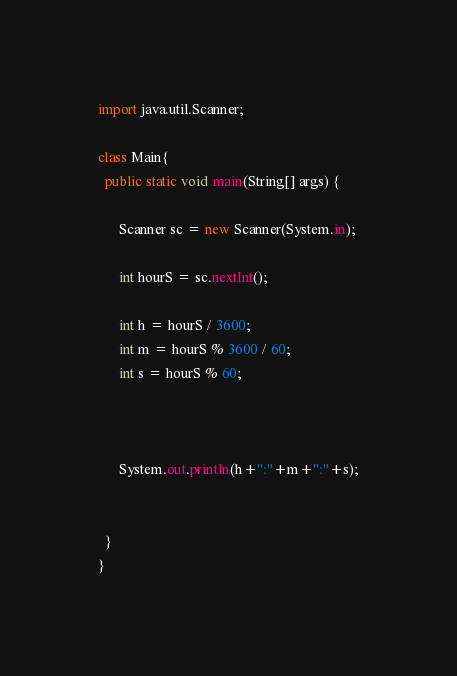<code> <loc_0><loc_0><loc_500><loc_500><_Java_>import java.util.Scanner;

class Main{
  public static void main(String[] args) {
    
	  Scanner sc = new Scanner(System.in);
	  
	  int hourS = sc.nextInt();
	  
	  int h = hourS / 3600;
	  int m = hourS % 3600 / 60;
	  int s = hourS % 60;
	  
	 
	  
	  System.out.println(h+":"+m+":"+s);
	 
	  
  }
}</code> 